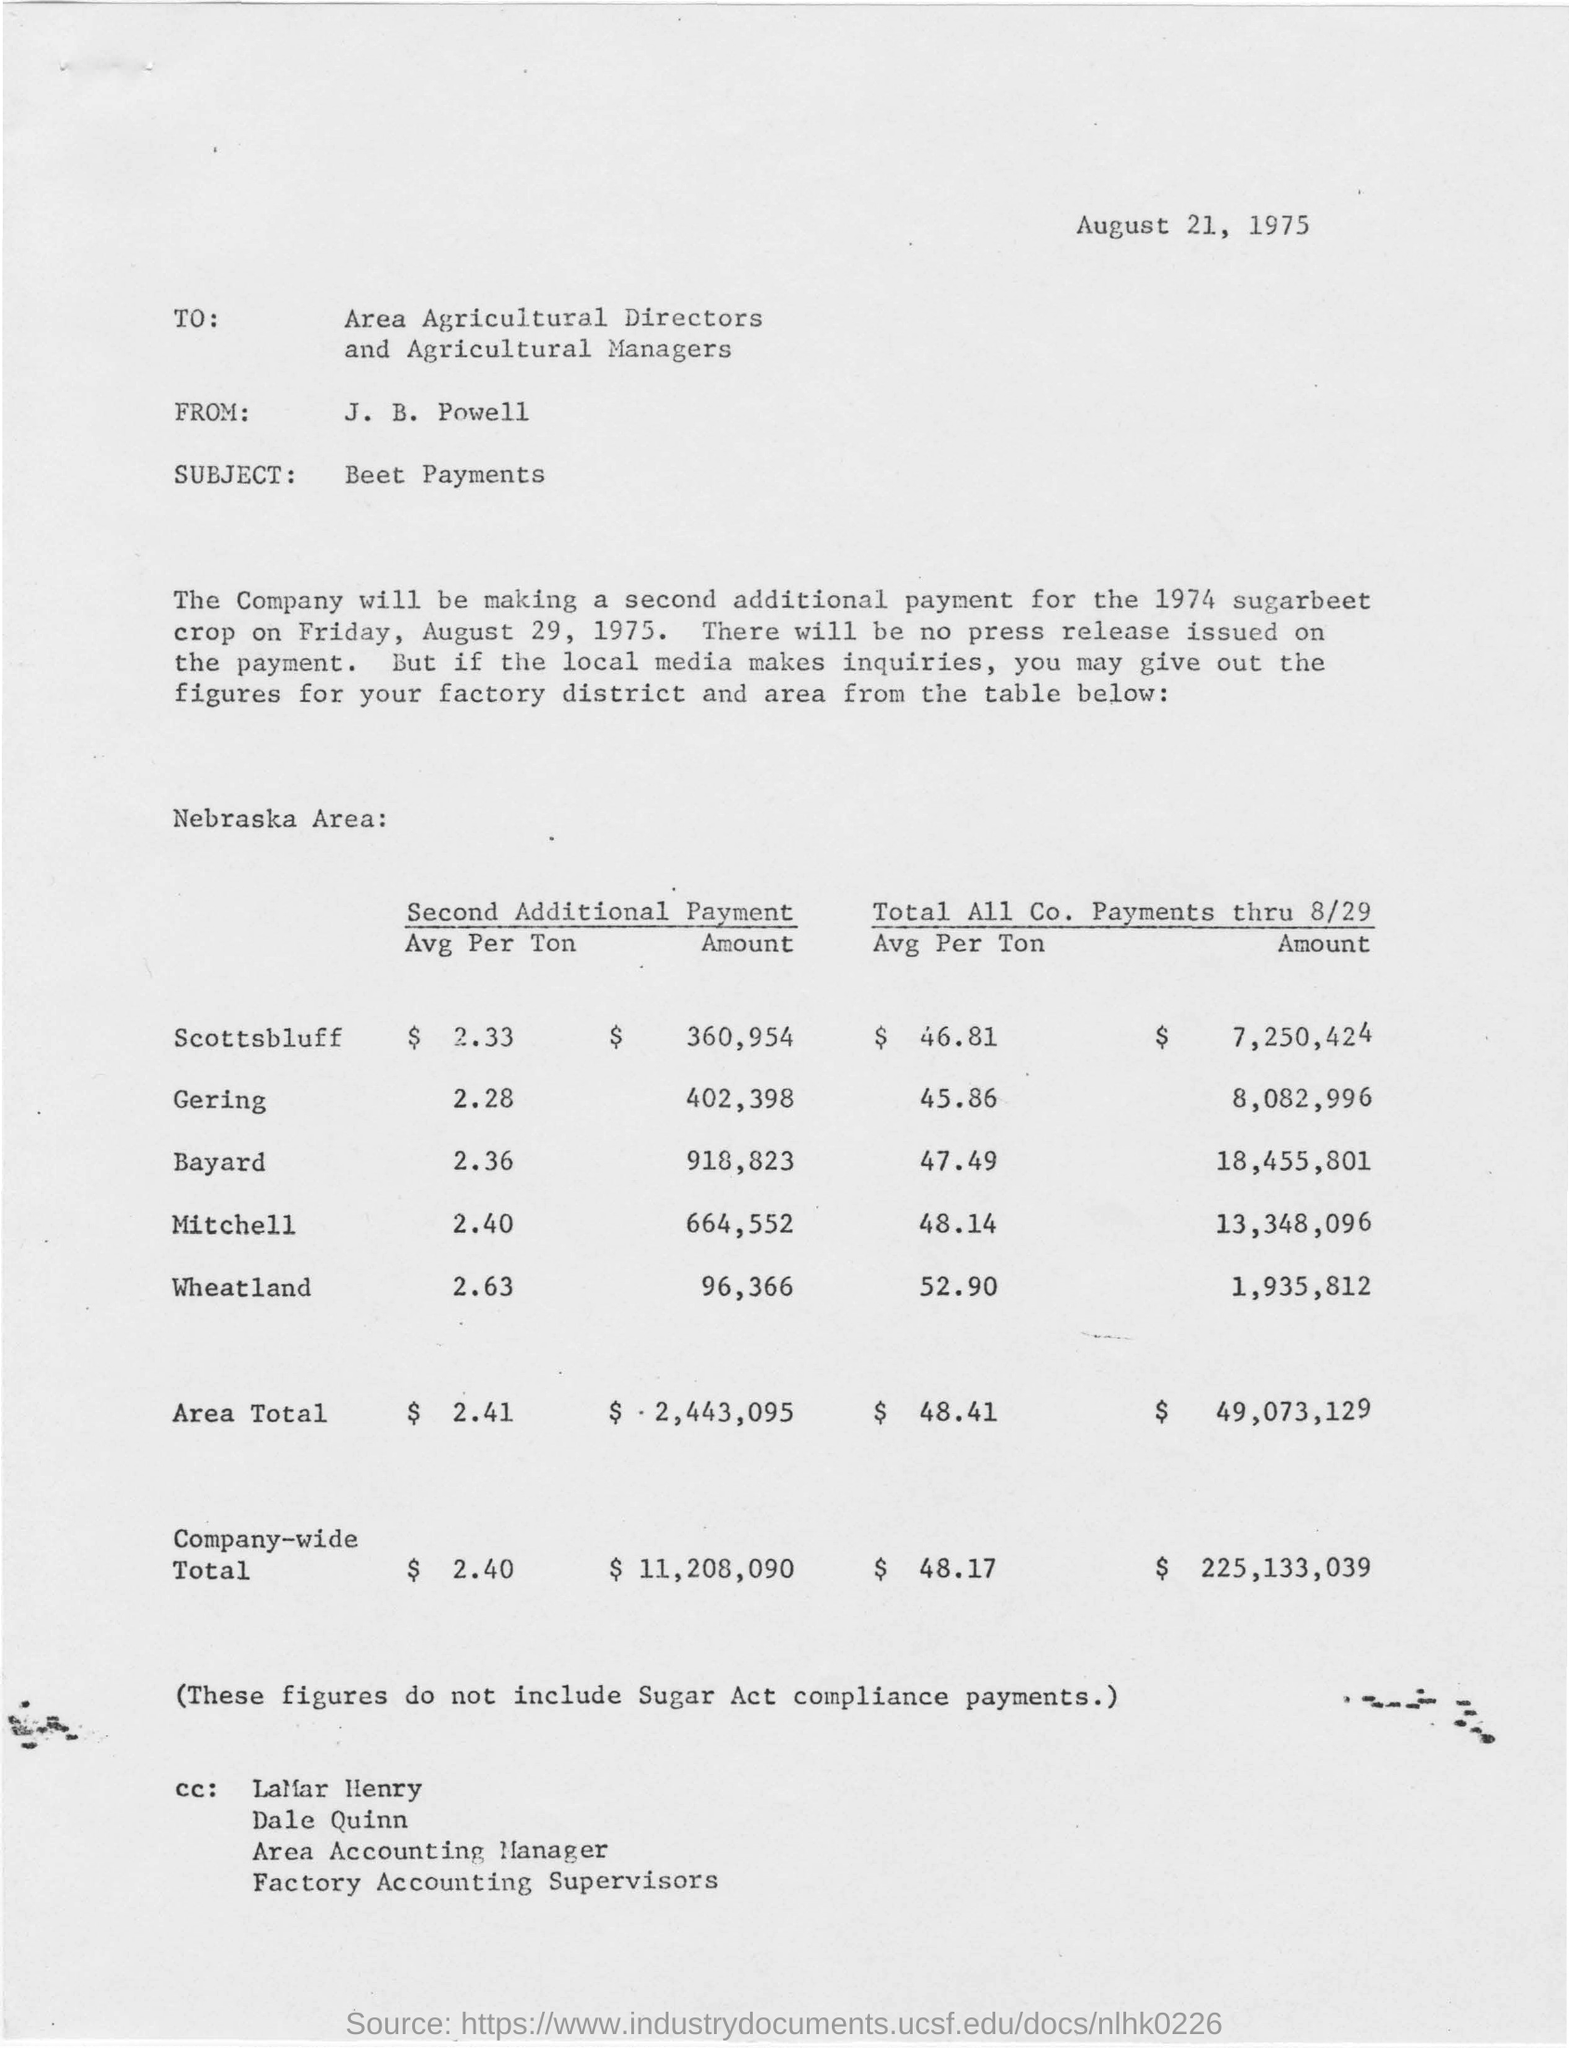What is the issued date of this letter?
Provide a short and direct response. August 21, 1975. Who is the sender of this letter?
Give a very brief answer. J. B. POWELL. Who is the receiver of the letter?
Your answer should be compact. AREA AGRICULTURAL DIRECTORS AND AGRICULTURAL MANAGERS. What is the subject of the letter?
Make the answer very short. Beet payments. 